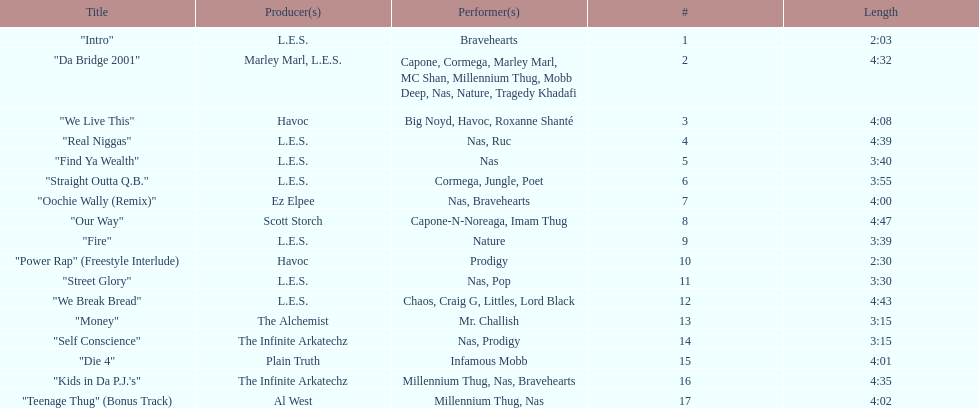Can you give me this table as a dict? {'header': ['Title', 'Producer(s)', 'Performer(s)', '#', 'Length'], 'rows': [['"Intro"', 'L.E.S.', 'Bravehearts', '1', '2:03'], ['"Da Bridge 2001"', 'Marley Marl, L.E.S.', 'Capone, Cormega, Marley Marl, MC Shan, Millennium Thug, Mobb Deep, Nas, Nature, Tragedy Khadafi', '2', '4:32'], ['"We Live This"', 'Havoc', 'Big Noyd, Havoc, Roxanne Shanté', '3', '4:08'], ['"Real Niggas"', 'L.E.S.', 'Nas, Ruc', '4', '4:39'], ['"Find Ya Wealth"', 'L.E.S.', 'Nas', '5', '3:40'], ['"Straight Outta Q.B."', 'L.E.S.', 'Cormega, Jungle, Poet', '6', '3:55'], ['"Oochie Wally (Remix)"', 'Ez Elpee', 'Nas, Bravehearts', '7', '4:00'], ['"Our Way"', 'Scott Storch', 'Capone-N-Noreaga, Imam Thug', '8', '4:47'], ['"Fire"', 'L.E.S.', 'Nature', '9', '3:39'], ['"Power Rap" (Freestyle Interlude)', 'Havoc', 'Prodigy', '10', '2:30'], ['"Street Glory"', 'L.E.S.', 'Nas, Pop', '11', '3:30'], ['"We Break Bread"', 'L.E.S.', 'Chaos, Craig G, Littles, Lord Black', '12', '4:43'], ['"Money"', 'The Alchemist', 'Mr. Challish', '13', '3:15'], ['"Self Conscience"', 'The Infinite Arkatechz', 'Nas, Prodigy', '14', '3:15'], ['"Die 4"', 'Plain Truth', 'Infamous Mobb', '15', '4:01'], ['"Kids in Da P.J.\'s"', 'The Infinite Arkatechz', 'Millennium Thug, Nas, Bravehearts', '16', '4:35'], ['"Teenage Thug" (Bonus Track)', 'Al West', 'Millennium Thug, Nas', '17', '4:02']]} What song was performed before "fire"? "Our Way". 